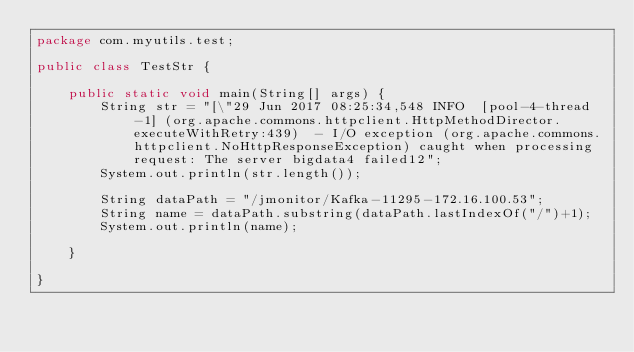<code> <loc_0><loc_0><loc_500><loc_500><_Java_>package com.myutils.test;

public class TestStr {

	public static void main(String[] args) {
		String str = "[\"29 Jun 2017 08:25:34,548 INFO  [pool-4-thread-1] (org.apache.commons.httpclient.HttpMethodDirector.executeWithRetry:439)  - I/O exception (org.apache.commons.httpclient.NoHttpResponseException) caught when processing request: The server bigdata4 failed12";
		System.out.println(str.length());
		
		String dataPath = "/jmonitor/Kafka-11295-172.16.100.53";
		String name = dataPath.substring(dataPath.lastIndexOf("/")+1);
		System.out.println(name);
		
	}
	
}
</code> 